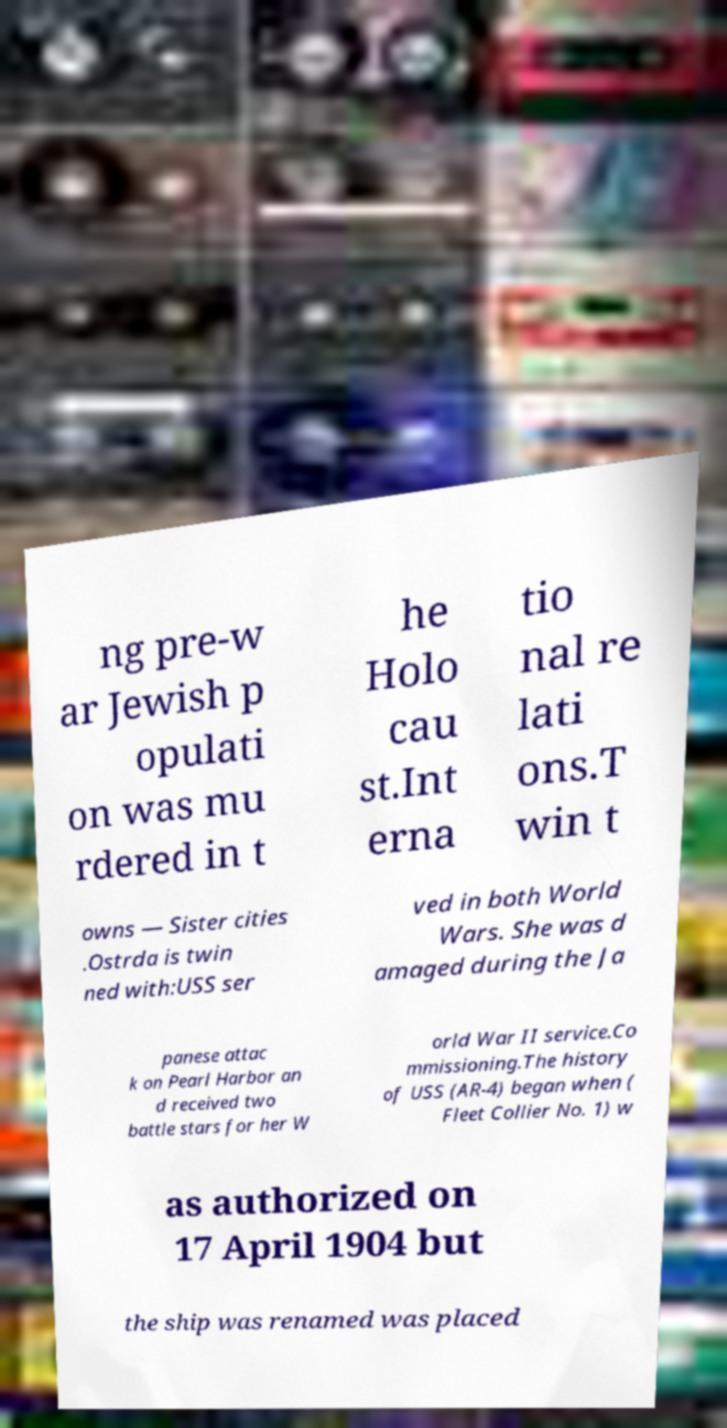Please read and relay the text visible in this image. What does it say? ng pre-w ar Jewish p opulati on was mu rdered in t he Holo cau st.Int erna tio nal re lati ons.T win t owns — Sister cities .Ostrda is twin ned with:USS ser ved in both World Wars. She was d amaged during the Ja panese attac k on Pearl Harbor an d received two battle stars for her W orld War II service.Co mmissioning.The history of USS (AR-4) began when ( Fleet Collier No. 1) w as authorized on 17 April 1904 but the ship was renamed was placed 